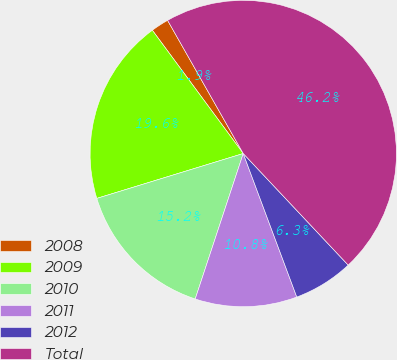Convert chart. <chart><loc_0><loc_0><loc_500><loc_500><pie_chart><fcel>2008<fcel>2009<fcel>2010<fcel>2011<fcel>2012<fcel>Total<nl><fcel>1.89%<fcel>19.62%<fcel>15.19%<fcel>10.76%<fcel>6.33%<fcel>46.21%<nl></chart> 